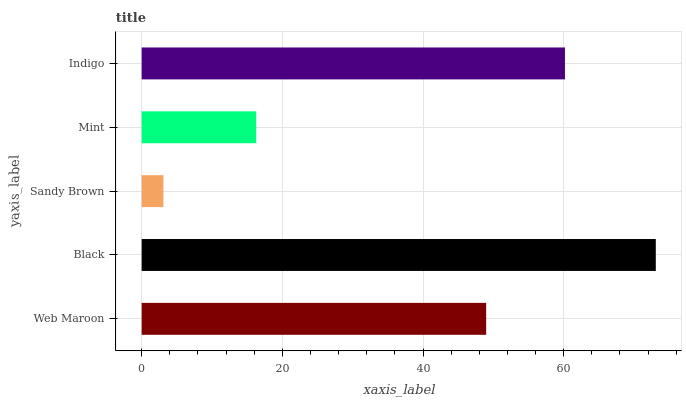Is Sandy Brown the minimum?
Answer yes or no. Yes. Is Black the maximum?
Answer yes or no. Yes. Is Black the minimum?
Answer yes or no. No. Is Sandy Brown the maximum?
Answer yes or no. No. Is Black greater than Sandy Brown?
Answer yes or no. Yes. Is Sandy Brown less than Black?
Answer yes or no. Yes. Is Sandy Brown greater than Black?
Answer yes or no. No. Is Black less than Sandy Brown?
Answer yes or no. No. Is Web Maroon the high median?
Answer yes or no. Yes. Is Web Maroon the low median?
Answer yes or no. Yes. Is Black the high median?
Answer yes or no. No. Is Sandy Brown the low median?
Answer yes or no. No. 